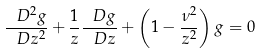<formula> <loc_0><loc_0><loc_500><loc_500>\frac { \ D ^ { 2 } g } { \ D z ^ { 2 } } + \frac { 1 } { z } \frac { \ D g } { \ D z } + \left ( 1 - \frac { \nu ^ { 2 } } { z ^ { 2 } } \right ) g = 0</formula> 